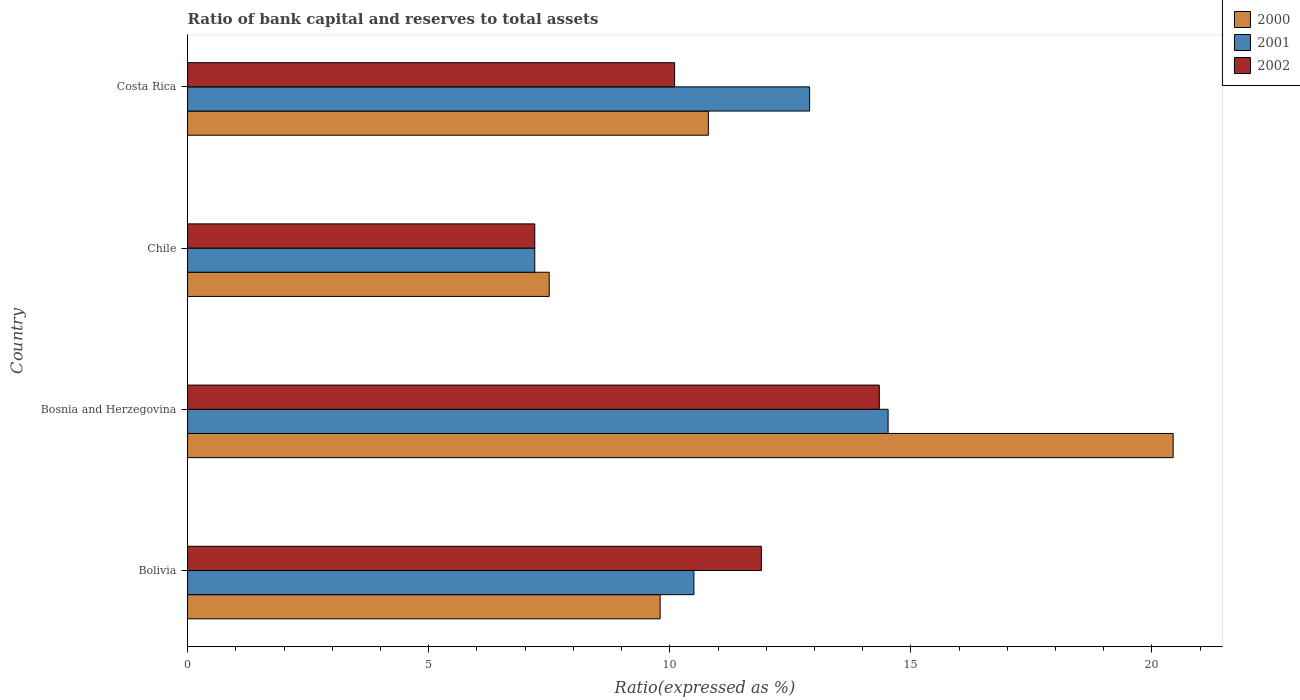How many different coloured bars are there?
Your response must be concise. 3. How many groups of bars are there?
Give a very brief answer. 4. Are the number of bars per tick equal to the number of legend labels?
Make the answer very short. Yes. How many bars are there on the 3rd tick from the top?
Ensure brevity in your answer.  3. In how many cases, is the number of bars for a given country not equal to the number of legend labels?
Offer a terse response. 0. What is the ratio of bank capital and reserves to total assets in 2000 in Chile?
Offer a very short reply. 7.5. Across all countries, what is the maximum ratio of bank capital and reserves to total assets in 2001?
Ensure brevity in your answer.  14.53. In which country was the ratio of bank capital and reserves to total assets in 2000 maximum?
Your response must be concise. Bosnia and Herzegovina. What is the total ratio of bank capital and reserves to total assets in 2001 in the graph?
Offer a very short reply. 45.13. What is the difference between the ratio of bank capital and reserves to total assets in 2000 in Bosnia and Herzegovina and that in Chile?
Make the answer very short. 12.94. What is the difference between the ratio of bank capital and reserves to total assets in 2000 in Bolivia and the ratio of bank capital and reserves to total assets in 2002 in Costa Rica?
Your answer should be very brief. -0.3. What is the average ratio of bank capital and reserves to total assets in 2000 per country?
Ensure brevity in your answer.  12.13. What is the difference between the ratio of bank capital and reserves to total assets in 2002 and ratio of bank capital and reserves to total assets in 2000 in Costa Rica?
Keep it short and to the point. -0.7. What is the ratio of the ratio of bank capital and reserves to total assets in 2001 in Bosnia and Herzegovina to that in Chile?
Give a very brief answer. 2.02. What is the difference between the highest and the second highest ratio of bank capital and reserves to total assets in 2001?
Your response must be concise. 1.63. What is the difference between the highest and the lowest ratio of bank capital and reserves to total assets in 2001?
Offer a terse response. 7.33. Is the sum of the ratio of bank capital and reserves to total assets in 2002 in Bolivia and Bosnia and Herzegovina greater than the maximum ratio of bank capital and reserves to total assets in 2000 across all countries?
Make the answer very short. Yes. What does the 3rd bar from the bottom in Chile represents?
Ensure brevity in your answer.  2002. How many bars are there?
Your answer should be compact. 12. Are all the bars in the graph horizontal?
Your answer should be very brief. Yes. Does the graph contain grids?
Provide a short and direct response. No. Where does the legend appear in the graph?
Your answer should be compact. Top right. How many legend labels are there?
Make the answer very short. 3. What is the title of the graph?
Your answer should be compact. Ratio of bank capital and reserves to total assets. What is the label or title of the X-axis?
Provide a succinct answer. Ratio(expressed as %). What is the Ratio(expressed as %) in 2000 in Bolivia?
Make the answer very short. 9.8. What is the Ratio(expressed as %) in 2001 in Bolivia?
Your answer should be very brief. 10.5. What is the Ratio(expressed as %) of 2000 in Bosnia and Herzegovina?
Your answer should be compact. 20.44. What is the Ratio(expressed as %) in 2001 in Bosnia and Herzegovina?
Your answer should be compact. 14.53. What is the Ratio(expressed as %) in 2002 in Bosnia and Herzegovina?
Offer a very short reply. 14.35. What is the Ratio(expressed as %) in 2002 in Chile?
Keep it short and to the point. 7.2. What is the Ratio(expressed as %) of 2002 in Costa Rica?
Offer a very short reply. 10.1. Across all countries, what is the maximum Ratio(expressed as %) in 2000?
Offer a very short reply. 20.44. Across all countries, what is the maximum Ratio(expressed as %) of 2001?
Ensure brevity in your answer.  14.53. Across all countries, what is the maximum Ratio(expressed as %) of 2002?
Ensure brevity in your answer.  14.35. Across all countries, what is the minimum Ratio(expressed as %) of 2000?
Your response must be concise. 7.5. Across all countries, what is the minimum Ratio(expressed as %) in 2002?
Your response must be concise. 7.2. What is the total Ratio(expressed as %) of 2000 in the graph?
Keep it short and to the point. 48.54. What is the total Ratio(expressed as %) in 2001 in the graph?
Keep it short and to the point. 45.13. What is the total Ratio(expressed as %) of 2002 in the graph?
Keep it short and to the point. 43.55. What is the difference between the Ratio(expressed as %) in 2000 in Bolivia and that in Bosnia and Herzegovina?
Provide a succinct answer. -10.64. What is the difference between the Ratio(expressed as %) in 2001 in Bolivia and that in Bosnia and Herzegovina?
Make the answer very short. -4.03. What is the difference between the Ratio(expressed as %) of 2002 in Bolivia and that in Bosnia and Herzegovina?
Your answer should be compact. -2.45. What is the difference between the Ratio(expressed as %) in 2000 in Bolivia and that in Chile?
Ensure brevity in your answer.  2.3. What is the difference between the Ratio(expressed as %) of 2000 in Bolivia and that in Costa Rica?
Keep it short and to the point. -1. What is the difference between the Ratio(expressed as %) of 2001 in Bolivia and that in Costa Rica?
Your answer should be compact. -2.4. What is the difference between the Ratio(expressed as %) in 2000 in Bosnia and Herzegovina and that in Chile?
Keep it short and to the point. 12.94. What is the difference between the Ratio(expressed as %) of 2001 in Bosnia and Herzegovina and that in Chile?
Keep it short and to the point. 7.33. What is the difference between the Ratio(expressed as %) of 2002 in Bosnia and Herzegovina and that in Chile?
Your answer should be very brief. 7.15. What is the difference between the Ratio(expressed as %) in 2000 in Bosnia and Herzegovina and that in Costa Rica?
Keep it short and to the point. 9.64. What is the difference between the Ratio(expressed as %) of 2001 in Bosnia and Herzegovina and that in Costa Rica?
Provide a short and direct response. 1.63. What is the difference between the Ratio(expressed as %) in 2002 in Bosnia and Herzegovina and that in Costa Rica?
Provide a short and direct response. 4.25. What is the difference between the Ratio(expressed as %) of 2001 in Chile and that in Costa Rica?
Your answer should be compact. -5.7. What is the difference between the Ratio(expressed as %) of 2000 in Bolivia and the Ratio(expressed as %) of 2001 in Bosnia and Herzegovina?
Ensure brevity in your answer.  -4.73. What is the difference between the Ratio(expressed as %) in 2000 in Bolivia and the Ratio(expressed as %) in 2002 in Bosnia and Herzegovina?
Provide a succinct answer. -4.55. What is the difference between the Ratio(expressed as %) of 2001 in Bolivia and the Ratio(expressed as %) of 2002 in Bosnia and Herzegovina?
Provide a short and direct response. -3.85. What is the difference between the Ratio(expressed as %) in 2000 in Bolivia and the Ratio(expressed as %) in 2001 in Chile?
Give a very brief answer. 2.6. What is the difference between the Ratio(expressed as %) in 2000 in Bolivia and the Ratio(expressed as %) in 2002 in Costa Rica?
Keep it short and to the point. -0.3. What is the difference between the Ratio(expressed as %) of 2000 in Bosnia and Herzegovina and the Ratio(expressed as %) of 2001 in Chile?
Provide a short and direct response. 13.24. What is the difference between the Ratio(expressed as %) in 2000 in Bosnia and Herzegovina and the Ratio(expressed as %) in 2002 in Chile?
Offer a very short reply. 13.24. What is the difference between the Ratio(expressed as %) in 2001 in Bosnia and Herzegovina and the Ratio(expressed as %) in 2002 in Chile?
Provide a short and direct response. 7.33. What is the difference between the Ratio(expressed as %) of 2000 in Bosnia and Herzegovina and the Ratio(expressed as %) of 2001 in Costa Rica?
Your answer should be very brief. 7.54. What is the difference between the Ratio(expressed as %) in 2000 in Bosnia and Herzegovina and the Ratio(expressed as %) in 2002 in Costa Rica?
Provide a short and direct response. 10.34. What is the difference between the Ratio(expressed as %) in 2001 in Bosnia and Herzegovina and the Ratio(expressed as %) in 2002 in Costa Rica?
Give a very brief answer. 4.43. What is the difference between the Ratio(expressed as %) in 2000 in Chile and the Ratio(expressed as %) in 2002 in Costa Rica?
Ensure brevity in your answer.  -2.6. What is the average Ratio(expressed as %) of 2000 per country?
Provide a succinct answer. 12.13. What is the average Ratio(expressed as %) in 2001 per country?
Provide a short and direct response. 11.28. What is the average Ratio(expressed as %) of 2002 per country?
Offer a very short reply. 10.89. What is the difference between the Ratio(expressed as %) of 2000 and Ratio(expressed as %) of 2001 in Bosnia and Herzegovina?
Keep it short and to the point. 5.91. What is the difference between the Ratio(expressed as %) in 2000 and Ratio(expressed as %) in 2002 in Bosnia and Herzegovina?
Keep it short and to the point. 6.09. What is the difference between the Ratio(expressed as %) of 2001 and Ratio(expressed as %) of 2002 in Bosnia and Herzegovina?
Your answer should be very brief. 0.18. What is the difference between the Ratio(expressed as %) of 2000 and Ratio(expressed as %) of 2001 in Chile?
Make the answer very short. 0.3. What is the difference between the Ratio(expressed as %) in 2000 and Ratio(expressed as %) in 2002 in Costa Rica?
Your answer should be very brief. 0.7. What is the ratio of the Ratio(expressed as %) of 2000 in Bolivia to that in Bosnia and Herzegovina?
Provide a short and direct response. 0.48. What is the ratio of the Ratio(expressed as %) in 2001 in Bolivia to that in Bosnia and Herzegovina?
Provide a short and direct response. 0.72. What is the ratio of the Ratio(expressed as %) in 2002 in Bolivia to that in Bosnia and Herzegovina?
Ensure brevity in your answer.  0.83. What is the ratio of the Ratio(expressed as %) of 2000 in Bolivia to that in Chile?
Your answer should be compact. 1.31. What is the ratio of the Ratio(expressed as %) in 2001 in Bolivia to that in Chile?
Make the answer very short. 1.46. What is the ratio of the Ratio(expressed as %) in 2002 in Bolivia to that in Chile?
Your answer should be compact. 1.65. What is the ratio of the Ratio(expressed as %) of 2000 in Bolivia to that in Costa Rica?
Your answer should be very brief. 0.91. What is the ratio of the Ratio(expressed as %) of 2001 in Bolivia to that in Costa Rica?
Make the answer very short. 0.81. What is the ratio of the Ratio(expressed as %) in 2002 in Bolivia to that in Costa Rica?
Provide a succinct answer. 1.18. What is the ratio of the Ratio(expressed as %) of 2000 in Bosnia and Herzegovina to that in Chile?
Keep it short and to the point. 2.73. What is the ratio of the Ratio(expressed as %) of 2001 in Bosnia and Herzegovina to that in Chile?
Your answer should be very brief. 2.02. What is the ratio of the Ratio(expressed as %) in 2002 in Bosnia and Herzegovina to that in Chile?
Provide a succinct answer. 1.99. What is the ratio of the Ratio(expressed as %) in 2000 in Bosnia and Herzegovina to that in Costa Rica?
Provide a succinct answer. 1.89. What is the ratio of the Ratio(expressed as %) of 2001 in Bosnia and Herzegovina to that in Costa Rica?
Your answer should be compact. 1.13. What is the ratio of the Ratio(expressed as %) of 2002 in Bosnia and Herzegovina to that in Costa Rica?
Offer a very short reply. 1.42. What is the ratio of the Ratio(expressed as %) in 2000 in Chile to that in Costa Rica?
Your answer should be compact. 0.69. What is the ratio of the Ratio(expressed as %) of 2001 in Chile to that in Costa Rica?
Keep it short and to the point. 0.56. What is the ratio of the Ratio(expressed as %) in 2002 in Chile to that in Costa Rica?
Make the answer very short. 0.71. What is the difference between the highest and the second highest Ratio(expressed as %) of 2000?
Provide a succinct answer. 9.64. What is the difference between the highest and the second highest Ratio(expressed as %) of 2001?
Make the answer very short. 1.63. What is the difference between the highest and the second highest Ratio(expressed as %) in 2002?
Offer a terse response. 2.45. What is the difference between the highest and the lowest Ratio(expressed as %) of 2000?
Your answer should be very brief. 12.94. What is the difference between the highest and the lowest Ratio(expressed as %) of 2001?
Provide a short and direct response. 7.33. What is the difference between the highest and the lowest Ratio(expressed as %) of 2002?
Make the answer very short. 7.15. 